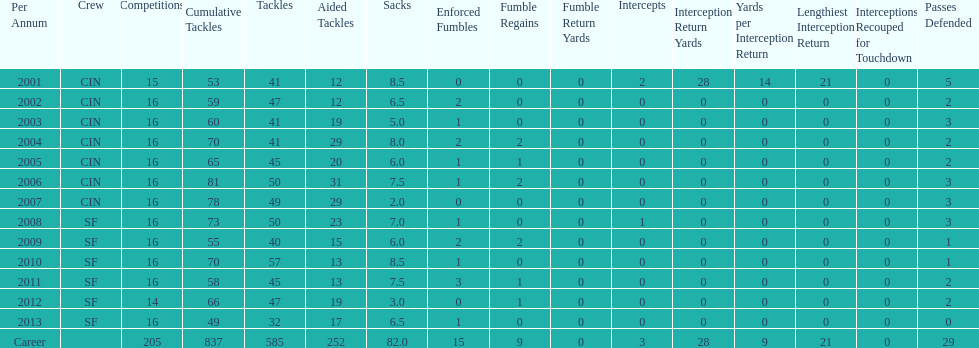What was the number of combined tackles in 2010? 70. 